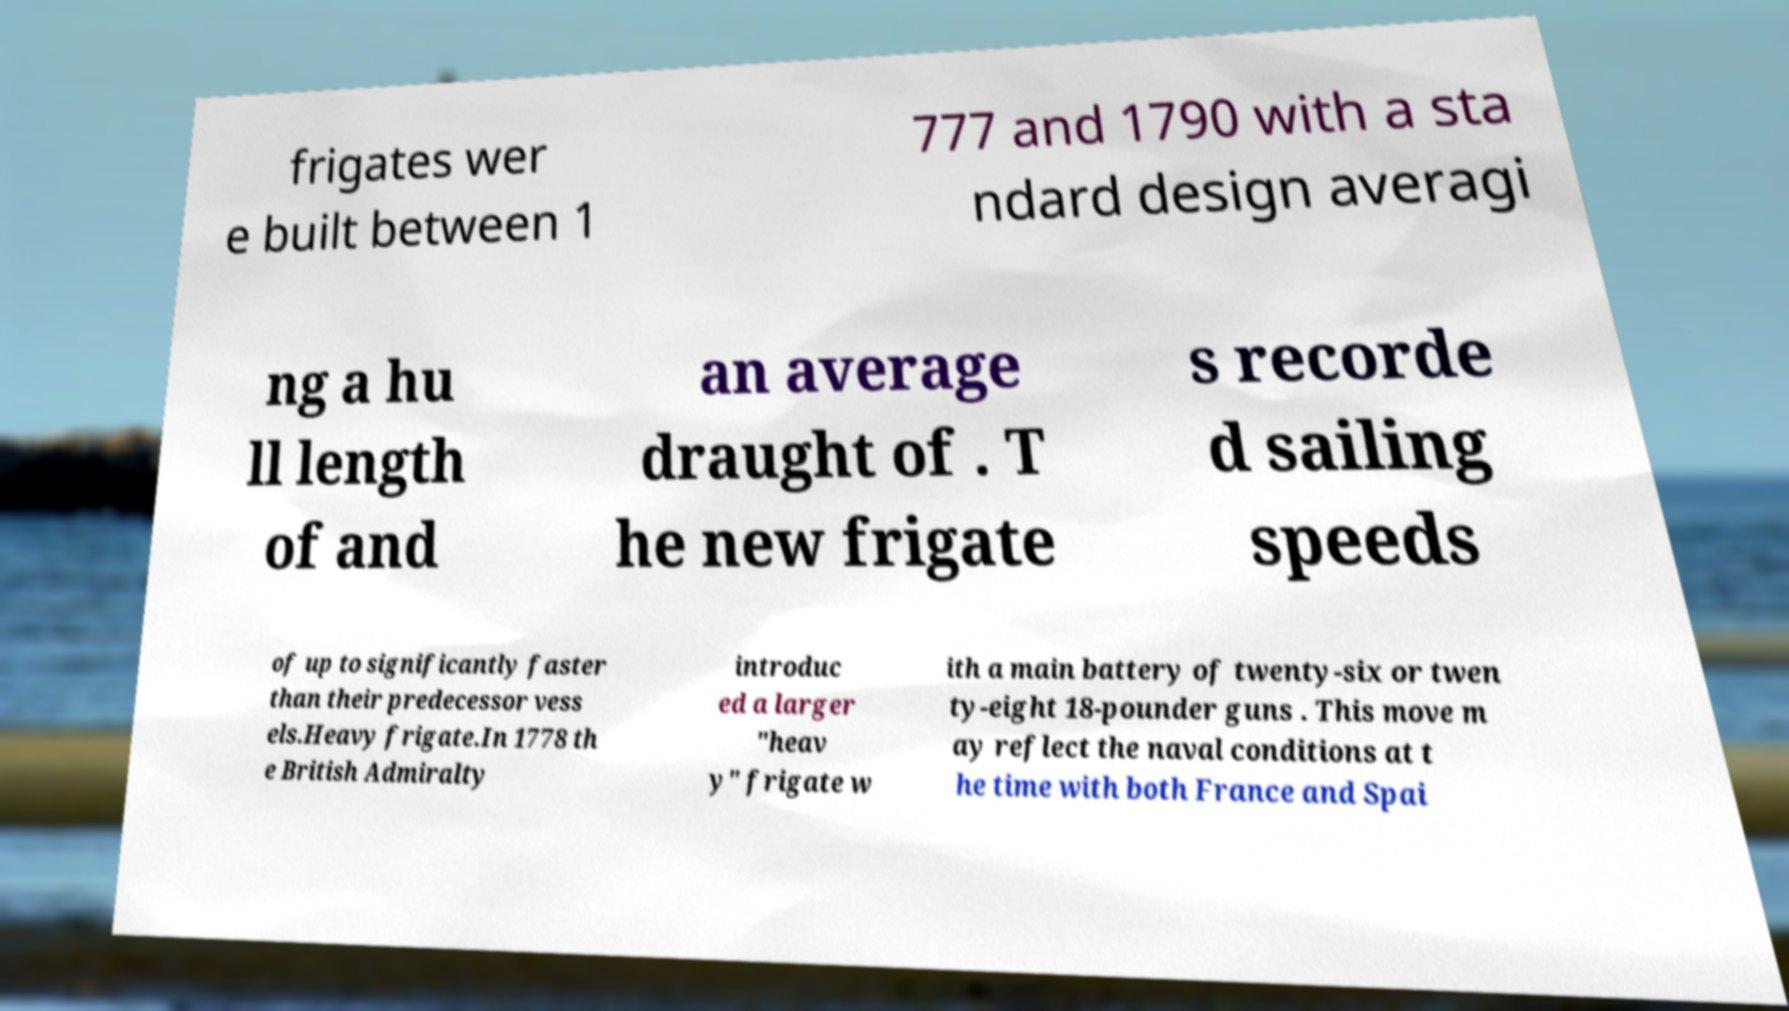Please identify and transcribe the text found in this image. frigates wer e built between 1 777 and 1790 with a sta ndard design averagi ng a hu ll length of and an average draught of . T he new frigate s recorde d sailing speeds of up to significantly faster than their predecessor vess els.Heavy frigate.In 1778 th e British Admiralty introduc ed a larger "heav y" frigate w ith a main battery of twenty-six or twen ty-eight 18-pounder guns . This move m ay reflect the naval conditions at t he time with both France and Spai 